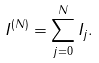Convert formula to latex. <formula><loc_0><loc_0><loc_500><loc_500>I ^ { ( N ) } = \sum _ { j = 0 } ^ { N } I _ { j } .</formula> 